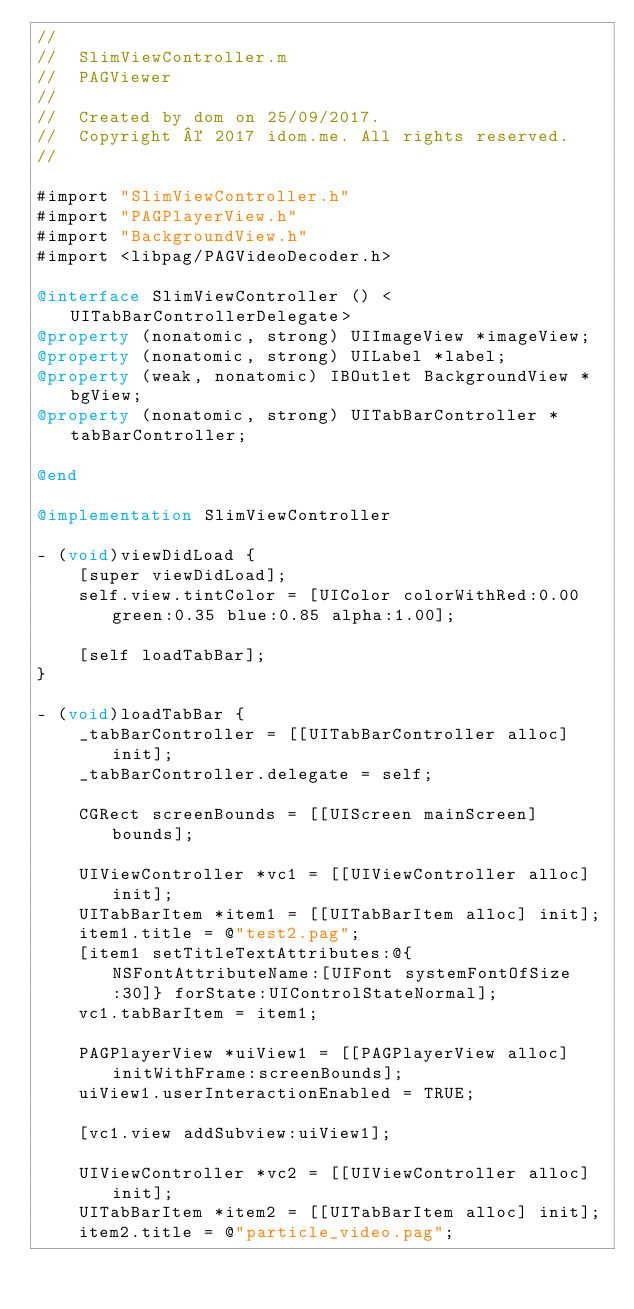<code> <loc_0><loc_0><loc_500><loc_500><_ObjectiveC_>//
//  SlimViewController.m
//  PAGViewer
//
//  Created by dom on 25/09/2017.
//  Copyright © 2017 idom.me. All rights reserved.
//

#import "SlimViewController.h"
#import "PAGPlayerView.h"
#import "BackgroundView.h"
#import <libpag/PAGVideoDecoder.h>

@interface SlimViewController () <UITabBarControllerDelegate>
@property (nonatomic, strong) UIImageView *imageView;
@property (nonatomic, strong) UILabel *label;
@property (weak, nonatomic) IBOutlet BackgroundView *bgView;
@property (nonatomic, strong) UITabBarController *tabBarController;

@end

@implementation SlimViewController

- (void)viewDidLoad {
    [super viewDidLoad];
    self.view.tintColor = [UIColor colorWithRed:0.00 green:0.35 blue:0.85 alpha:1.00];
    
    [self loadTabBar];
}

- (void)loadTabBar {
    _tabBarController = [[UITabBarController alloc] init];
    _tabBarController.delegate = self;
    
    CGRect screenBounds = [[UIScreen mainScreen] bounds];
    
    UIViewController *vc1 = [[UIViewController alloc] init];
    UITabBarItem *item1 = [[UITabBarItem alloc] init];
    item1.title = @"test2.pag";
    [item1 setTitleTextAttributes:@{NSFontAttributeName:[UIFont systemFontOfSize:30]} forState:UIControlStateNormal];
    vc1.tabBarItem = item1;
    
    PAGPlayerView *uiView1 = [[PAGPlayerView alloc] initWithFrame:screenBounds];
    uiView1.userInteractionEnabled = TRUE;
    
    [vc1.view addSubview:uiView1];
    
    UIViewController *vc2 = [[UIViewController alloc] init];
    UITabBarItem *item2 = [[UITabBarItem alloc] init];
    item2.title = @"particle_video.pag";</code> 